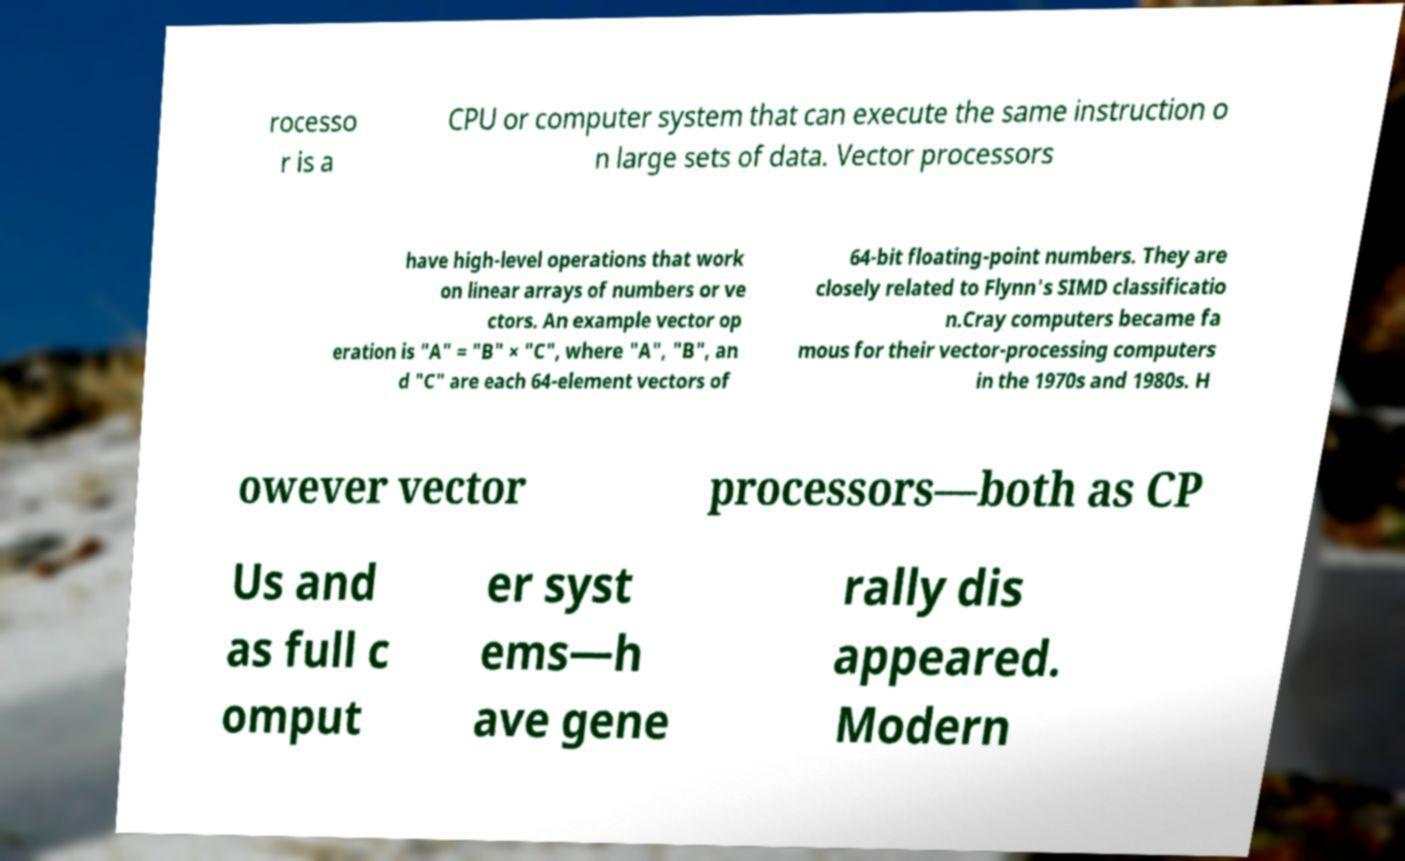What messages or text are displayed in this image? I need them in a readable, typed format. rocesso r is a CPU or computer system that can execute the same instruction o n large sets of data. Vector processors have high-level operations that work on linear arrays of numbers or ve ctors. An example vector op eration is "A" = "B" × "C", where "A", "B", an d "C" are each 64-element vectors of 64-bit floating-point numbers. They are closely related to Flynn's SIMD classificatio n.Cray computers became fa mous for their vector-processing computers in the 1970s and 1980s. H owever vector processors—both as CP Us and as full c omput er syst ems—h ave gene rally dis appeared. Modern 